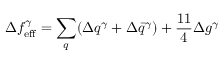<formula> <loc_0><loc_0><loc_500><loc_500>\Delta f _ { e f f } ^ { \gamma } = \sum _ { q } ( \Delta q ^ { \gamma } + \Delta \bar { q } ^ { \gamma } ) + \frac { 1 1 } { 4 } \Delta g ^ { \gamma }</formula> 